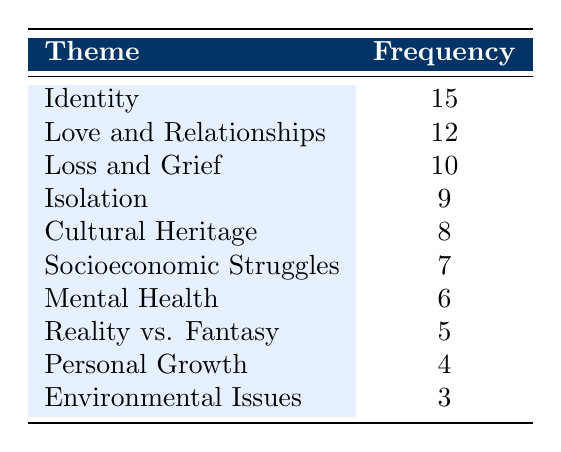What is the most frequently explored theme in the short stories? The table shows that the theme "Identity" has the highest frequency at 15, which indicates it is the most explored theme in the award-winning short stories.
Answer: Identity How many themes have a frequency of 7 or lower? The themes with a frequency of 7 or lower are "Socioeconomic Struggles" (7), "Mental Health" (6), "Reality vs. Fantasy" (5), "Personal Growth" (4), and "Environmental Issues" (3). That results in a total of 5 themes.
Answer: 5 Is "Loss and Grief" more frequently explored than "Isolation"? "Loss and Grief" has a frequency of 10, while "Isolation" has a frequency of 9, which means that "Loss and Grief" is indeed explored more frequently.
Answer: Yes What is the total frequency of themes related to personal development, such as "Personal Growth" and "Mental Health"? To find the total frequency, add the frequencies of "Personal Growth" (4) and "Mental Health" (6): 4 + 6 = 10. Therefore, the total frequency related to personal development is 10.
Answer: 10 Which theme has a frequency of 8? Referring to the table, "Cultural Heritage" has a frequency of 8.
Answer: Cultural Heritage What is the average frequency of the top three themes explored in the short stories? The top three themes are "Identity" (15), "Love and Relationships" (12), and "Loss and Grief" (10). To find the average: (15 + 12 + 10) / 3 = 37 / 3 = 12.33, making the average frequency of the top three themes approximately 12.33.
Answer: 12.33 Are there any themes with the same frequency? Looking at the table, each theme has a unique frequency value; hence, there are no themes with the same frequency.
Answer: No Which two themes combined have a frequency of 22? The themes "Identity" (15) and "Love and Relationships" (12) when combined total 15 + 12 = 27. The only combination yielding 22 is "Identity" (15) and "Loss and Grief" (10) since 15 + 10 = 25. Therefore, no combination matches 22.
Answer: No combination exists 